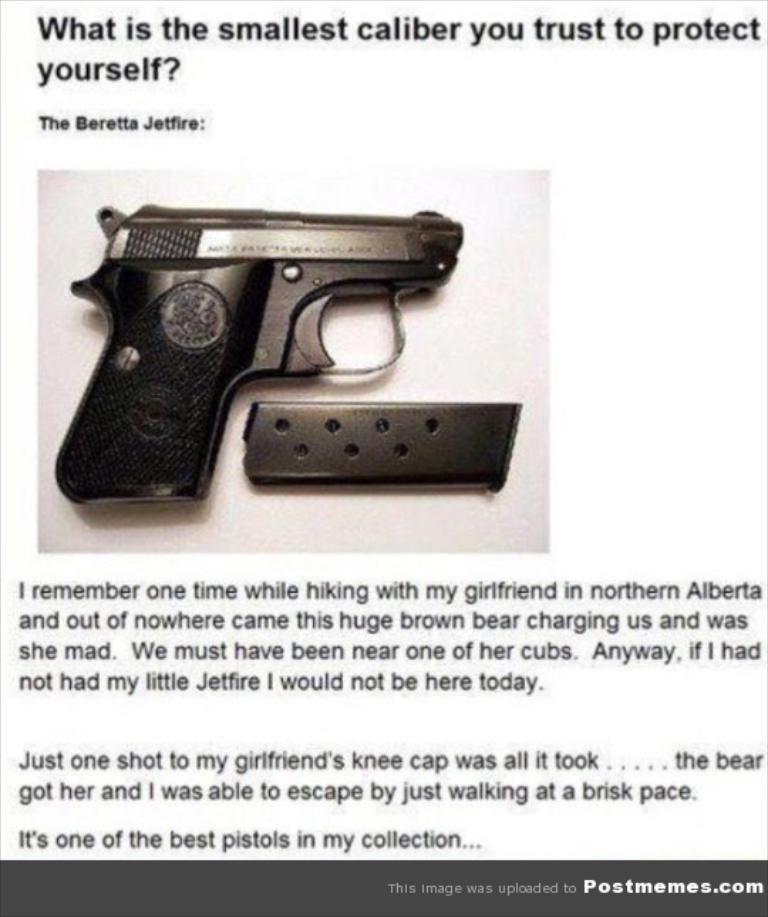Describe this image in one or two sentences. There is a poster which is having an image and black color texts. In the image, there is a gun and an object on a white color surface. In the bottom right, there is a watermark. And the background of this poster is white in color. 